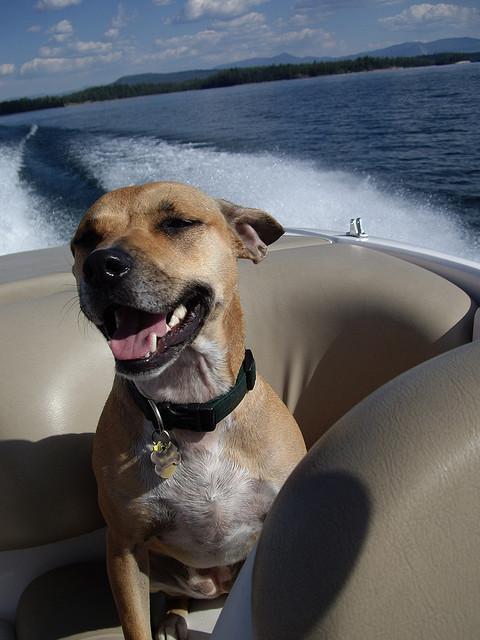How many vase in the picture?
Give a very brief answer. 0. 